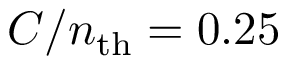Convert formula to latex. <formula><loc_0><loc_0><loc_500><loc_500>C / n _ { t h } = 0 . 2 5</formula> 